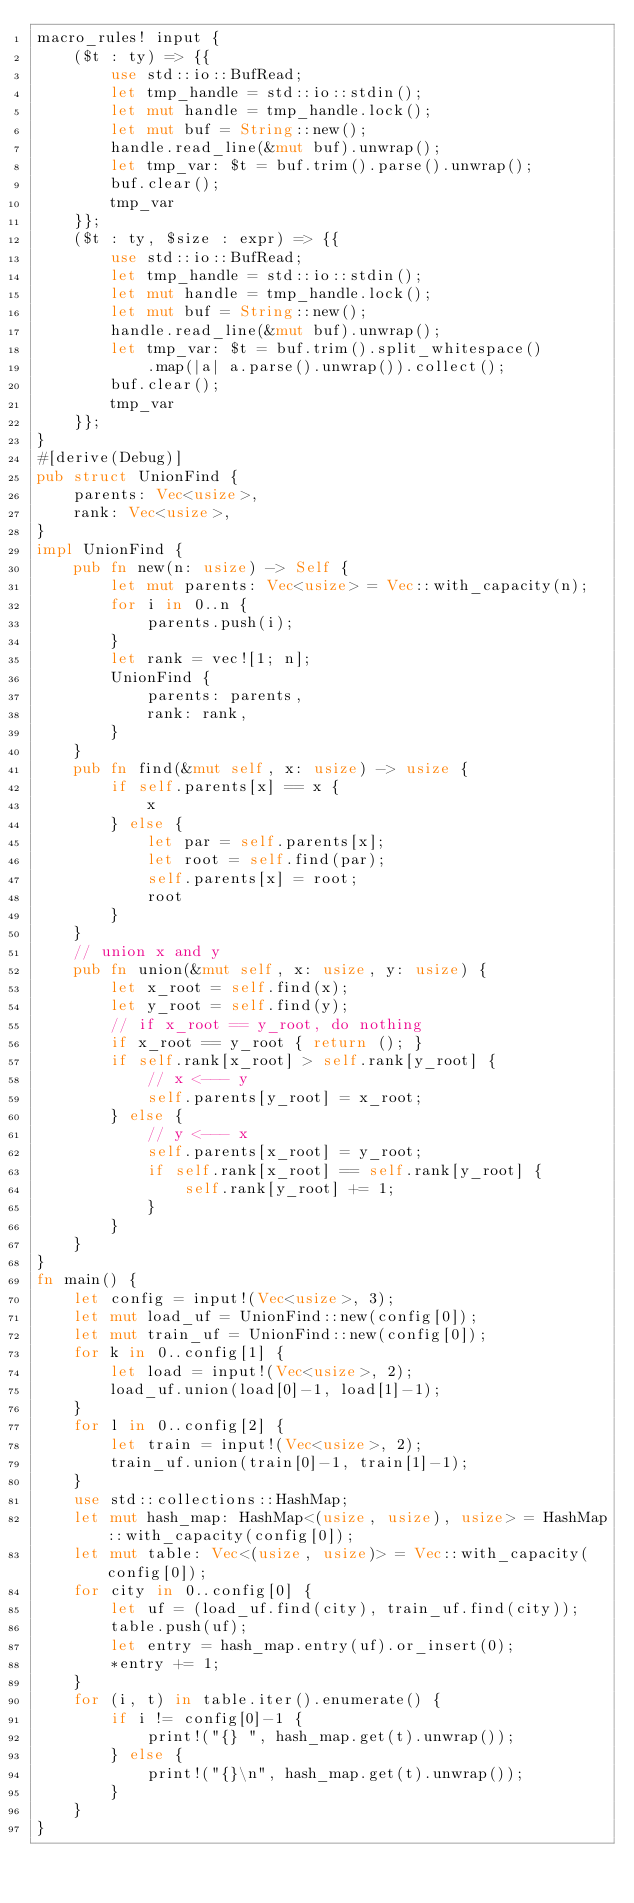Convert code to text. <code><loc_0><loc_0><loc_500><loc_500><_Rust_>macro_rules! input {
    ($t : ty) => {{
        use std::io::BufRead;
        let tmp_handle = std::io::stdin();
        let mut handle = tmp_handle.lock();
        let mut buf = String::new();
        handle.read_line(&mut buf).unwrap();
        let tmp_var: $t = buf.trim().parse().unwrap(); 
        buf.clear();
        tmp_var
    }};
    ($t : ty, $size : expr) => {{
        use std::io::BufRead;
        let tmp_handle = std::io::stdin();
        let mut handle = tmp_handle.lock();
        let mut buf = String::new();
        handle.read_line(&mut buf).unwrap();
        let tmp_var: $t = buf.trim().split_whitespace()
            .map(|a| a.parse().unwrap()).collect();
        buf.clear();
        tmp_var
    }};
}
#[derive(Debug)]
pub struct UnionFind {
    parents: Vec<usize>,
    rank: Vec<usize>,
}
impl UnionFind {
    pub fn new(n: usize) -> Self {
        let mut parents: Vec<usize> = Vec::with_capacity(n);
        for i in 0..n {
            parents.push(i);
        }
        let rank = vec![1; n];
        UnionFind {
            parents: parents,
            rank: rank,
        }
    }
    pub fn find(&mut self, x: usize) -> usize {
        if self.parents[x] == x {
            x
        } else {
            let par = self.parents[x];
            let root = self.find(par);
            self.parents[x] = root;
            root
        }
    }
    // union x and y
    pub fn union(&mut self, x: usize, y: usize) {
        let x_root = self.find(x);
        let y_root = self.find(y);
        // if x_root == y_root, do nothing
        if x_root == y_root { return (); }
        if self.rank[x_root] > self.rank[y_root] {
            // x <--- y
            self.parents[y_root] = x_root;
        } else {
            // y <--- x
            self.parents[x_root] = y_root;
            if self.rank[x_root] == self.rank[y_root] {
                self.rank[y_root] += 1;
            }
        }
    }
}
fn main() {
    let config = input!(Vec<usize>, 3);
    let mut load_uf = UnionFind::new(config[0]);
    let mut train_uf = UnionFind::new(config[0]);
    for k in 0..config[1] {
        let load = input!(Vec<usize>, 2);
        load_uf.union(load[0]-1, load[1]-1);
    }
    for l in 0..config[2] {
        let train = input!(Vec<usize>, 2);
        train_uf.union(train[0]-1, train[1]-1);
    }
    use std::collections::HashMap;
    let mut hash_map: HashMap<(usize, usize), usize> = HashMap::with_capacity(config[0]);
    let mut table: Vec<(usize, usize)> = Vec::with_capacity(config[0]);
    for city in 0..config[0] {
        let uf = (load_uf.find(city), train_uf.find(city)); 
        table.push(uf);
        let entry = hash_map.entry(uf).or_insert(0);
        *entry += 1;
    }
    for (i, t) in table.iter().enumerate() {
        if i != config[0]-1 {
            print!("{} ", hash_map.get(t).unwrap());
        } else {
            print!("{}\n", hash_map.get(t).unwrap());
        }
    }
}
</code> 